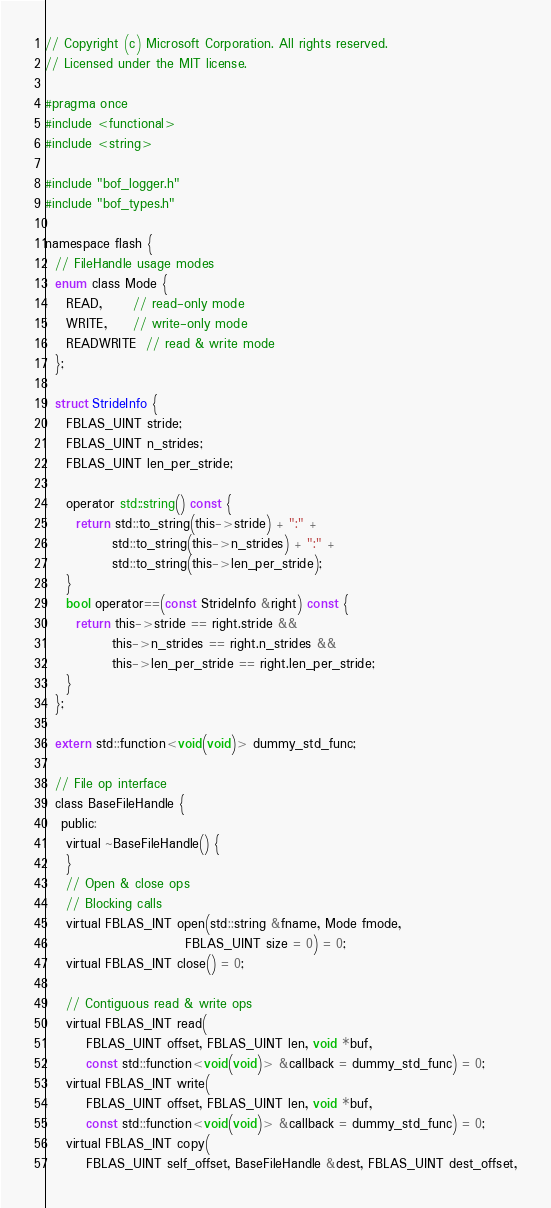<code> <loc_0><loc_0><loc_500><loc_500><_C_>// Copyright (c) Microsoft Corporation. All rights reserved.
// Licensed under the MIT license.

#pragma once
#include <functional>
#include <string>

#include "bof_logger.h"
#include "bof_types.h"

namespace flash {
  // FileHandle usage modes
  enum class Mode {
    READ,      // read-only mode
    WRITE,     // write-only mode
    READWRITE  // read & write mode
  };

  struct StrideInfo {
    FBLAS_UINT stride;
    FBLAS_UINT n_strides;
    FBLAS_UINT len_per_stride;

    operator std::string() const {
      return std::to_string(this->stride) + ":" +
             std::to_string(this->n_strides) + ":" +
             std::to_string(this->len_per_stride);
    }
    bool operator==(const StrideInfo &right) const {
      return this->stride == right.stride &&
             this->n_strides == right.n_strides &&
             this->len_per_stride == right.len_per_stride;
    }
  };

  extern std::function<void(void)> dummy_std_func;

  // File op interface
  class BaseFileHandle {
   public:
    virtual ~BaseFileHandle() {
    }
    // Open & close ops
    // Blocking calls
    virtual FBLAS_INT open(std::string &fname, Mode fmode,
                           FBLAS_UINT size = 0) = 0;
    virtual FBLAS_INT close() = 0;

    // Contiguous read & write ops
    virtual FBLAS_INT read(
        FBLAS_UINT offset, FBLAS_UINT len, void *buf,
        const std::function<void(void)> &callback = dummy_std_func) = 0;
    virtual FBLAS_INT write(
        FBLAS_UINT offset, FBLAS_UINT len, void *buf,
        const std::function<void(void)> &callback = dummy_std_func) = 0;
    virtual FBLAS_INT copy(
        FBLAS_UINT self_offset, BaseFileHandle &dest, FBLAS_UINT dest_offset,</code> 